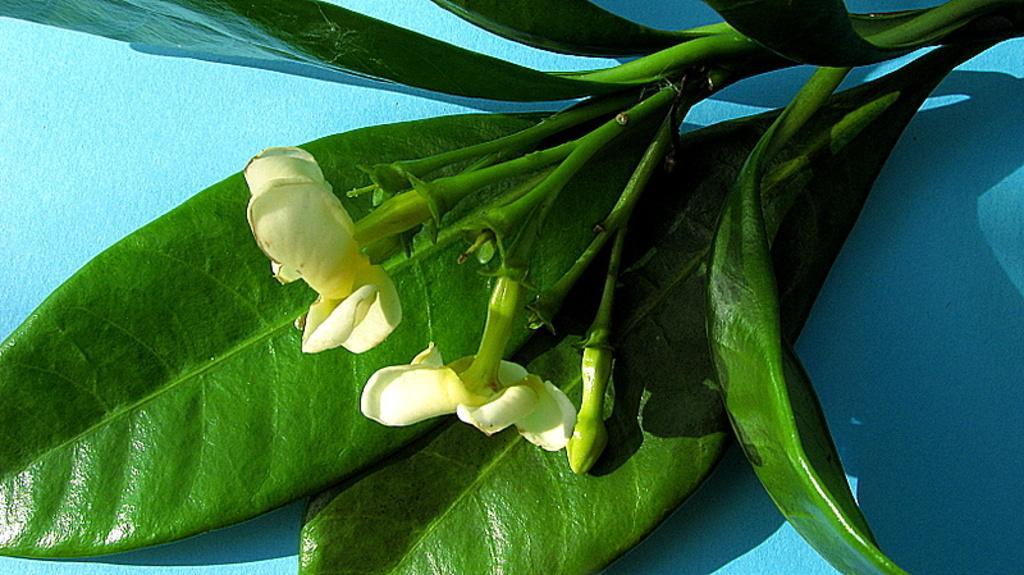Can you describe this image briefly? In the image there are two white flowers to a plant in front of the blue wall. 